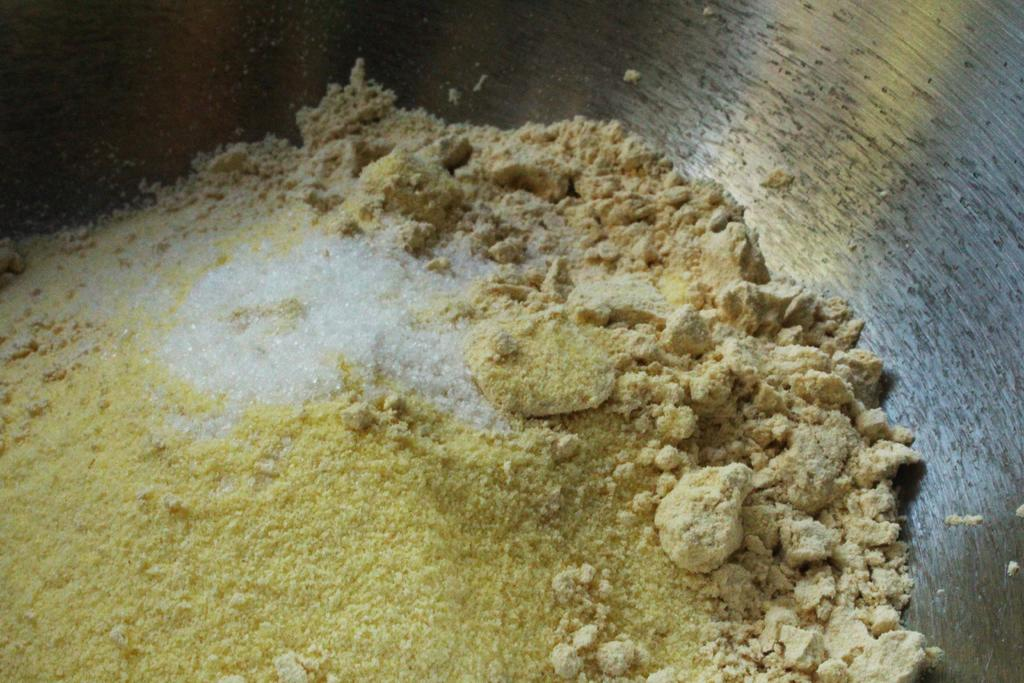What is in the bowl that is visible in the image? There is a bowl in the image. What is inside the bowl? The bowl contains powders. Can you describe the colors of the powders? The powders have yellow, cream, and white colors. How does the volcano affect the powders in the image? There is no volcano present in the image, so it cannot affect the powders. 